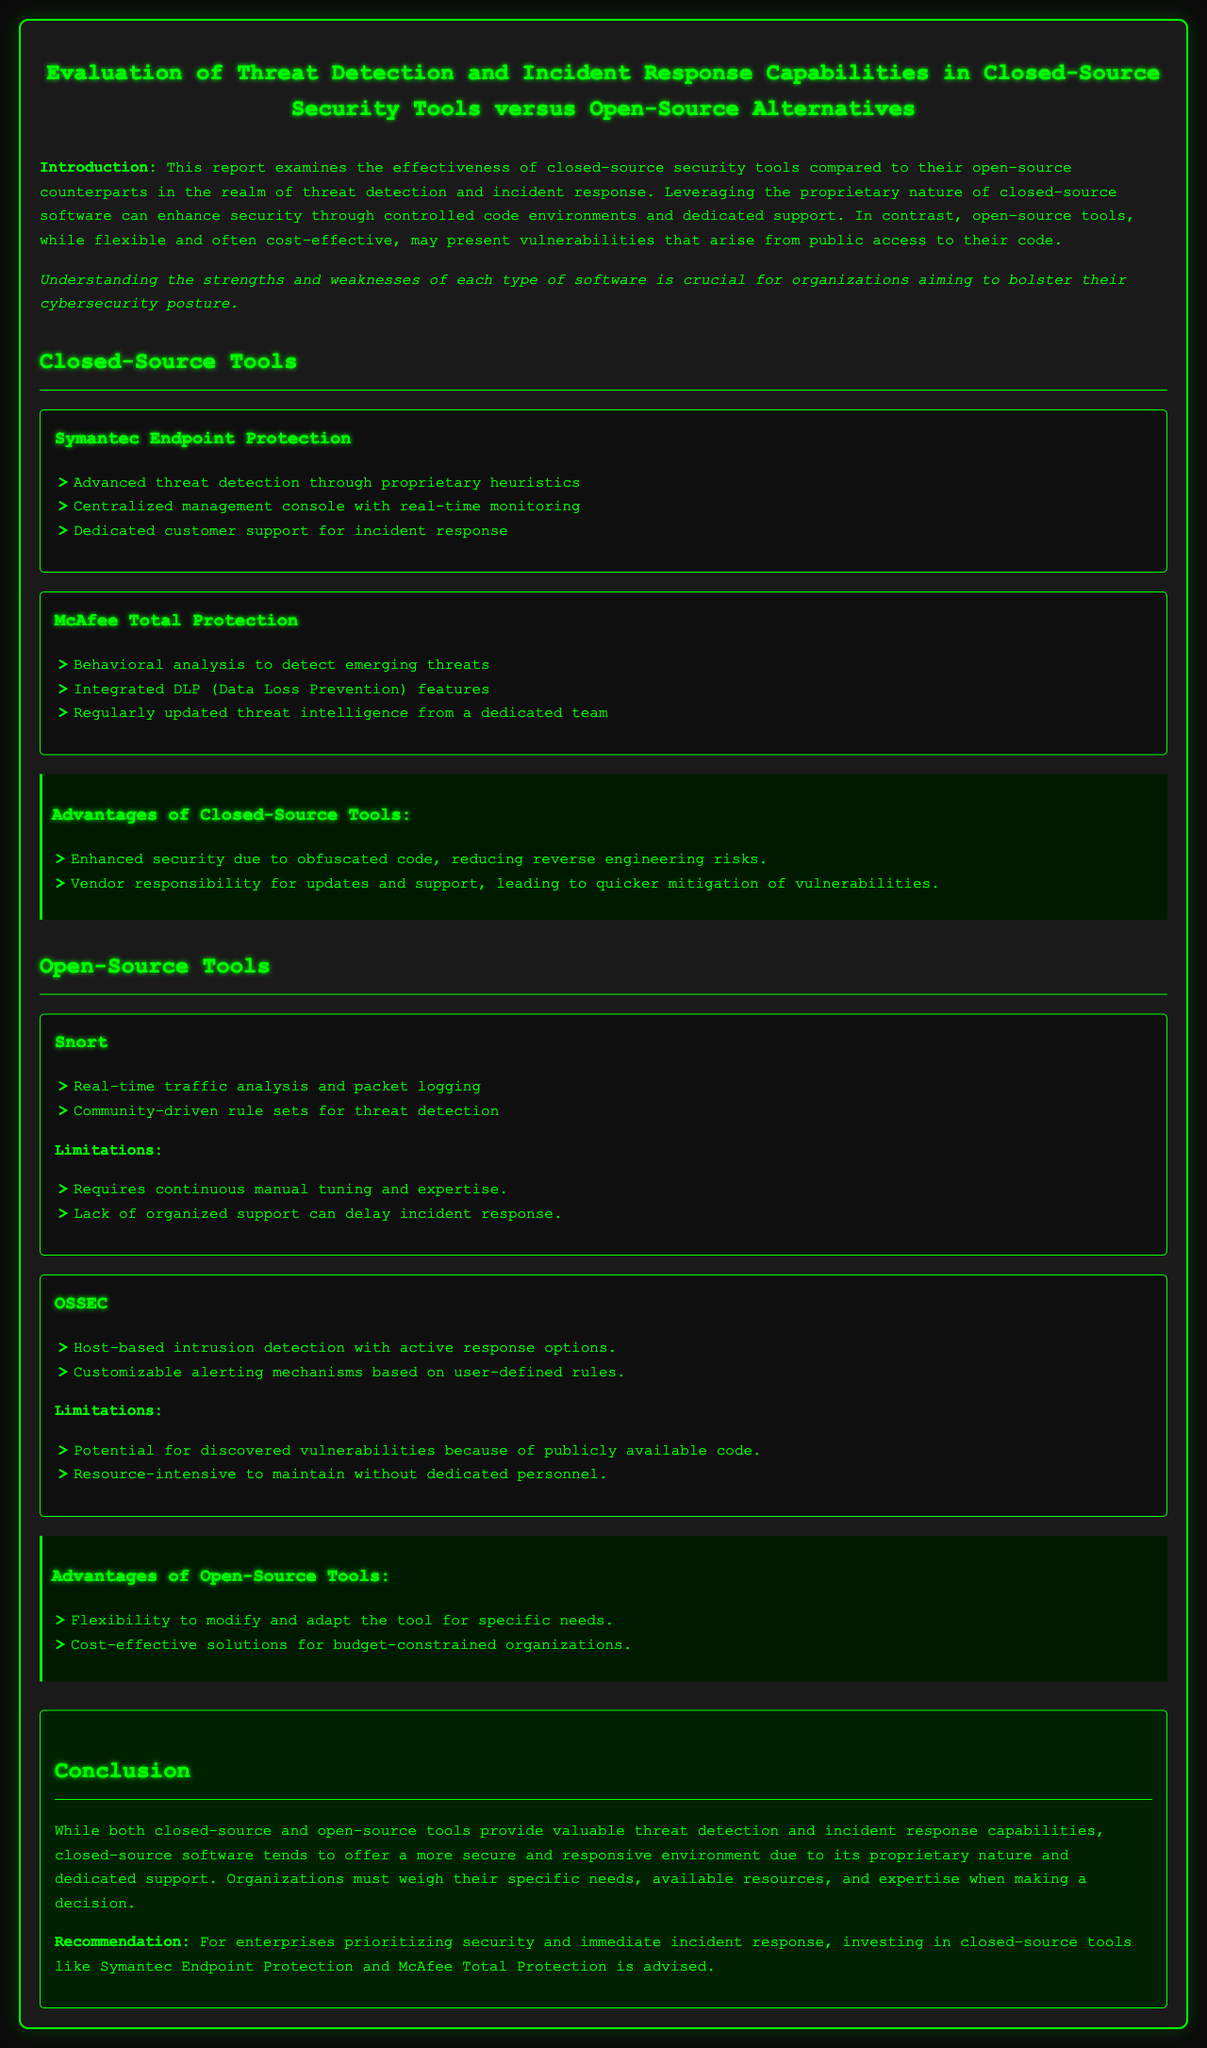What are the names of the two closed-source tools mentioned? The report lists Symantec Endpoint Protection and McAfee Total Protection as closed-source tools.
Answer: Symantec Endpoint Protection, McAfee Total Protection What feature does McAfee Total Protection include? The document states that McAfee Total Protection includes Behavioral analysis to detect emerging threats.
Answer: Behavioral analysis What limitation is associated with the open-source tool Snort? The report notes that Snort requires continuous manual tuning and expertise as a limitation.
Answer: Continuous manual tuning and expertise What is the primary recommendation for enterprises based on the conclusion? The recommendation suggests that enterprises should invest in closed-source tools for better security and incident response.
Answer: Invest in closed-source tools How many advantages of closed-source tools are listed in the document? The section lists two advantages of closed-source tools.
Answer: Two 